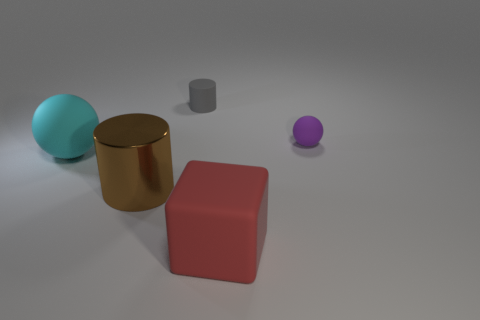Is the number of small blocks greater than the number of small purple rubber balls?
Provide a short and direct response. No. Are there any other large red cylinders made of the same material as the big cylinder?
Offer a very short reply. No. What is the shape of the matte object that is both in front of the tiny purple thing and behind the metallic cylinder?
Ensure brevity in your answer.  Sphere. How many other things are there of the same shape as the tiny gray thing?
Give a very brief answer. 1. What is the size of the block?
Make the answer very short. Large. How many objects are either tiny purple objects or large brown metallic spheres?
Your response must be concise. 1. What size is the rubber sphere on the right side of the metal cylinder?
Offer a terse response. Small. Are there any other things that are the same size as the red rubber block?
Make the answer very short. Yes. There is a rubber object that is both to the left of the small purple rubber sphere and behind the cyan sphere; what is its color?
Ensure brevity in your answer.  Gray. Are the tiny thing that is in front of the small gray object and the large block made of the same material?
Provide a short and direct response. Yes. 